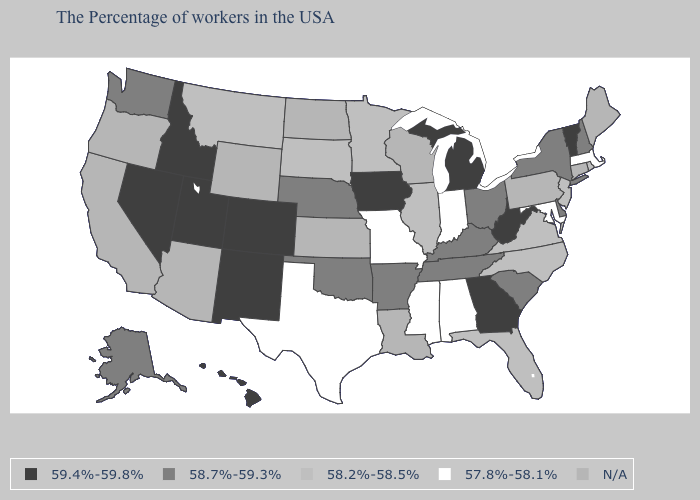What is the value of Indiana?
Write a very short answer. 57.8%-58.1%. Does Vermont have the highest value in the Northeast?
Short answer required. Yes. What is the value of North Carolina?
Answer briefly. 58.2%-58.5%. What is the lowest value in states that border Wyoming?
Be succinct. 58.2%-58.5%. Name the states that have a value in the range 57.8%-58.1%?
Write a very short answer. Massachusetts, Maryland, Indiana, Alabama, Mississippi, Missouri, Texas. What is the value of Georgia?
Keep it brief. 59.4%-59.8%. Does West Virginia have the highest value in the South?
Quick response, please. Yes. How many symbols are there in the legend?
Concise answer only. 5. Name the states that have a value in the range 57.8%-58.1%?
Concise answer only. Massachusetts, Maryland, Indiana, Alabama, Mississippi, Missouri, Texas. What is the value of Washington?
Keep it brief. 58.7%-59.3%. What is the value of Vermont?
Give a very brief answer. 59.4%-59.8%. Name the states that have a value in the range 57.8%-58.1%?
Quick response, please. Massachusetts, Maryland, Indiana, Alabama, Mississippi, Missouri, Texas. What is the highest value in states that border North Carolina?
Give a very brief answer. 59.4%-59.8%. What is the value of Arkansas?
Keep it brief. 58.7%-59.3%. What is the value of New Jersey?
Quick response, please. 58.2%-58.5%. 